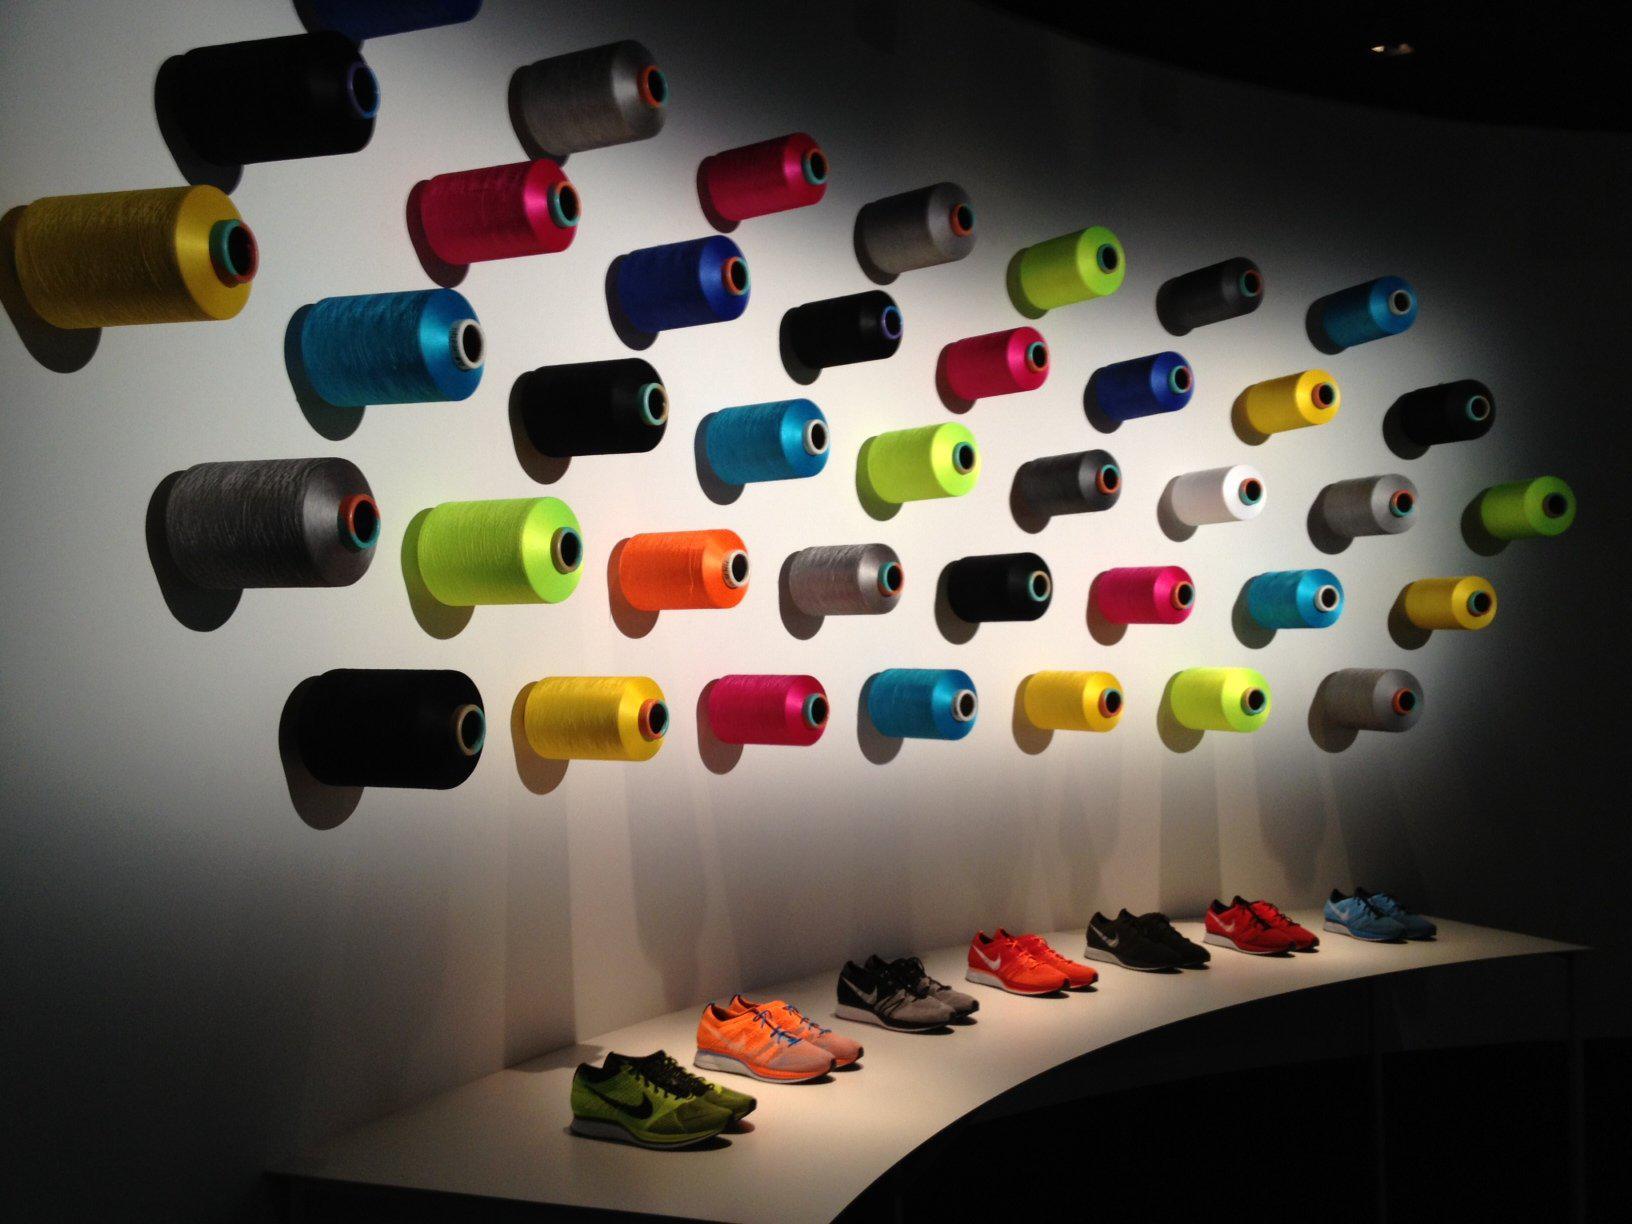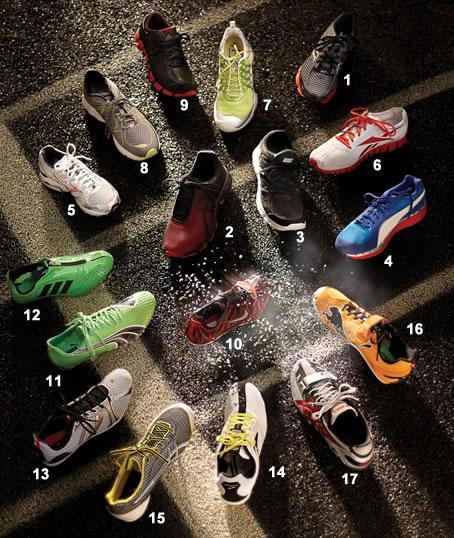The first image is the image on the left, the second image is the image on the right. Evaluate the accuracy of this statement regarding the images: "There are many shoes in the image to the right.". Is it true? Answer yes or no. Yes. The first image is the image on the left, the second image is the image on the right. Assess this claim about the two images: "There are at least 8 shoes.". Correct or not? Answer yes or no. Yes. 